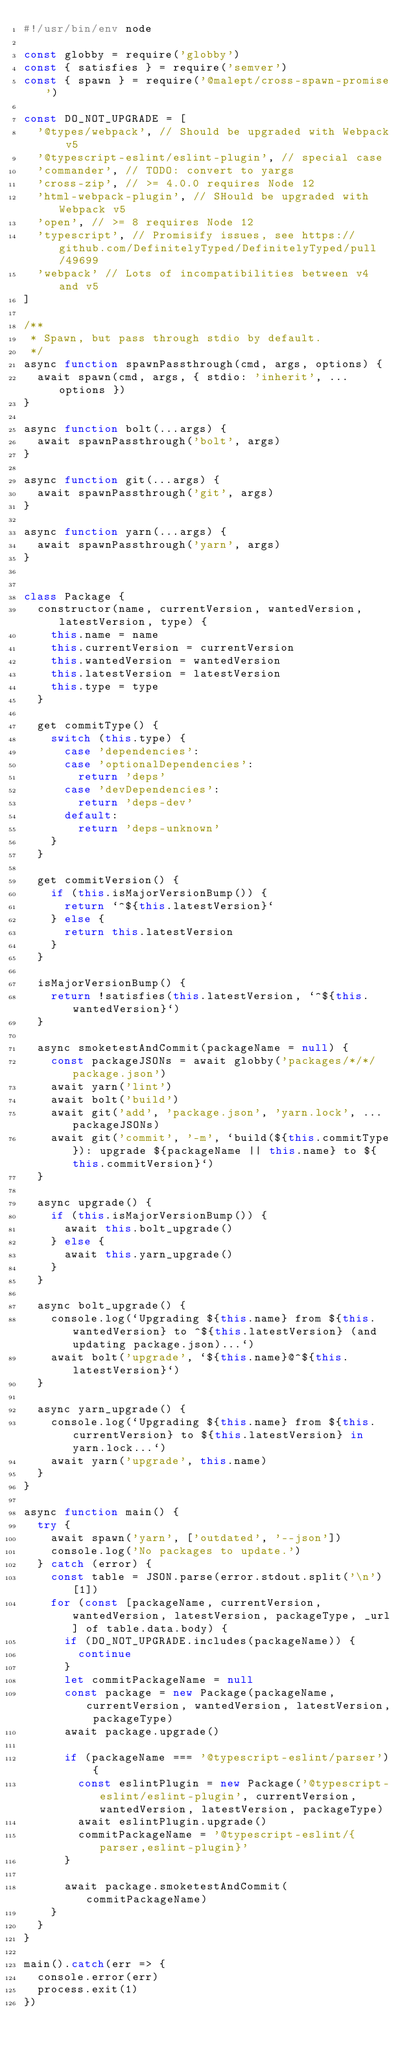<code> <loc_0><loc_0><loc_500><loc_500><_JavaScript_>#!/usr/bin/env node

const globby = require('globby')
const { satisfies } = require('semver')
const { spawn } = require('@malept/cross-spawn-promise')

const DO_NOT_UPGRADE = [
  '@types/webpack', // Should be upgraded with Webpack v5
  '@typescript-eslint/eslint-plugin', // special case
  'commander', // TODO: convert to yargs
  'cross-zip', // >= 4.0.0 requires Node 12
  'html-webpack-plugin', // SHould be upgraded with Webpack v5
  'open', // >= 8 requires Node 12
  'typescript', // Promisify issues, see https://github.com/DefinitelyTyped/DefinitelyTyped/pull/49699
  'webpack' // Lots of incompatibilities between v4 and v5
]

/**
 * Spawn, but pass through stdio by default.
 */
async function spawnPassthrough(cmd, args, options) {
  await spawn(cmd, args, { stdio: 'inherit', ...options })
}

async function bolt(...args) {
  await spawnPassthrough('bolt', args)
}

async function git(...args) {
  await spawnPassthrough('git', args)
}

async function yarn(...args) {
  await spawnPassthrough('yarn', args)
}


class Package {
  constructor(name, currentVersion, wantedVersion, latestVersion, type) {
    this.name = name
    this.currentVersion = currentVersion
    this.wantedVersion = wantedVersion
    this.latestVersion = latestVersion
    this.type = type
  }

  get commitType() {
    switch (this.type) {
      case 'dependencies':
      case 'optionalDependencies':
        return 'deps'
      case 'devDependencies':
        return 'deps-dev'
      default:
        return 'deps-unknown'
    }
  }

  get commitVersion() {
    if (this.isMajorVersionBump()) {
      return `^${this.latestVersion}`
    } else {
      return this.latestVersion
    }
  }

  isMajorVersionBump() {
    return !satisfies(this.latestVersion, `^${this.wantedVersion}`)
  }

  async smoketestAndCommit(packageName = null) {
    const packageJSONs = await globby('packages/*/*/package.json')
    await yarn('lint')
    await bolt('build')
    await git('add', 'package.json', 'yarn.lock', ...packageJSONs)
    await git('commit', '-m', `build(${this.commitType}): upgrade ${packageName || this.name} to ${this.commitVersion}`)
  }

  async upgrade() {
    if (this.isMajorVersionBump()) {
      await this.bolt_upgrade()
    } else {
      await this.yarn_upgrade()
    }
  }

  async bolt_upgrade() {
    console.log(`Upgrading ${this.name} from ${this.wantedVersion} to ^${this.latestVersion} (and updating package.json)...`)
    await bolt('upgrade', `${this.name}@^${this.latestVersion}`)
  }

  async yarn_upgrade() {
    console.log(`Upgrading ${this.name} from ${this.currentVersion} to ${this.latestVersion} in yarn.lock...`)
    await yarn('upgrade', this.name)
  }
}

async function main() {
  try {
    await spawn('yarn', ['outdated', '--json'])
    console.log('No packages to update.')
  } catch (error) {
    const table = JSON.parse(error.stdout.split('\n')[1])
    for (const [packageName, currentVersion, wantedVersion, latestVersion, packageType, _url] of table.data.body) {
      if (DO_NOT_UPGRADE.includes(packageName)) {
        continue
      }
      let commitPackageName = null
      const package = new Package(packageName, currentVersion, wantedVersion, latestVersion, packageType)
      await package.upgrade()

      if (packageName === '@typescript-eslint/parser') {
        const eslintPlugin = new Package('@typescript-eslint/eslint-plugin', currentVersion, wantedVersion, latestVersion, packageType)
        await eslintPlugin.upgrade()
        commitPackageName = '@typescript-eslint/{parser,eslint-plugin}'
      }

      await package.smoketestAndCommit(commitPackageName)
    }
  }
}

main().catch(err => {
  console.error(err)
  process.exit(1)
})
</code> 